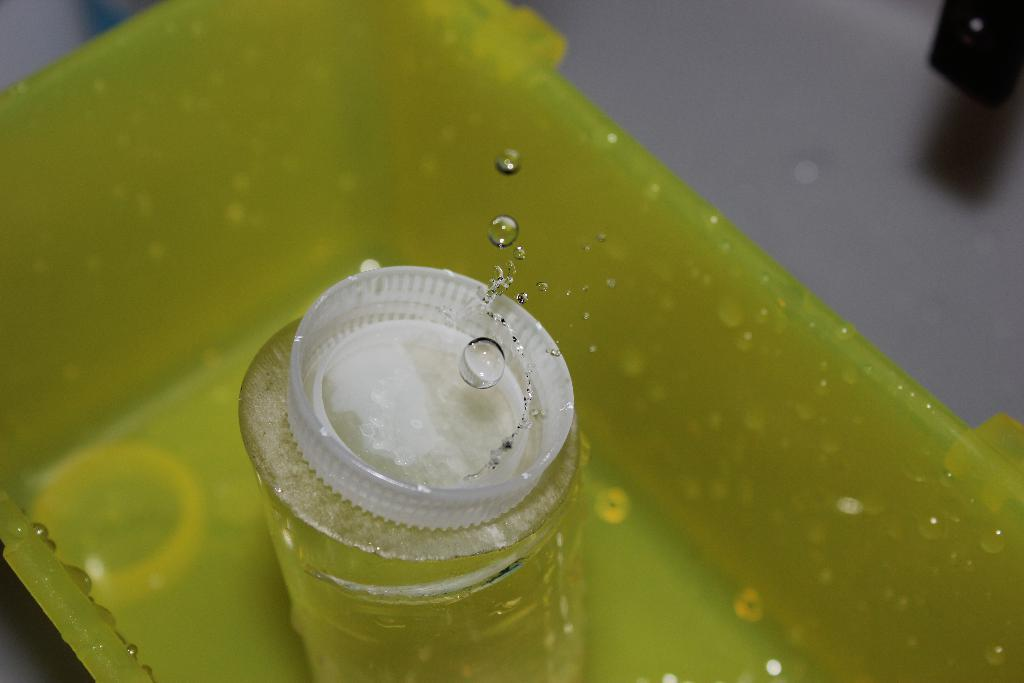What is the main object in the image? There is a vessel in the image. What is covering the opening of the vessel? There is a cap on the vessel. Can you describe the surroundings of the cap? Water droplets are visible near the cap. What type of oil is being heated on the stove in the image? There is no stove or oil present in the image; it only features a vessel with a cap and water droplets. Can you see a train passing by in the image? There is no train visible in the image. 